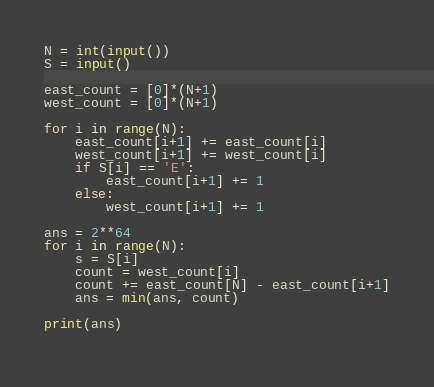Convert code to text. <code><loc_0><loc_0><loc_500><loc_500><_Python_>N = int(input())
S = input()

east_count = [0]*(N+1)
west_count = [0]*(N+1)

for i in range(N):
    east_count[i+1] += east_count[i]
    west_count[i+1] += west_count[i]
    if S[i] == 'E':
        east_count[i+1] += 1
    else:
        west_count[i+1] += 1

ans = 2**64
for i in range(N):
    s = S[i]
    count = west_count[i]
    count += east_count[N] - east_count[i+1]
    ans = min(ans, count)

print(ans)
    
</code> 